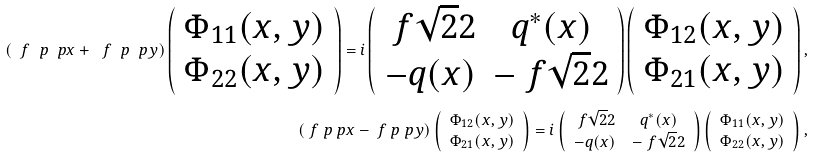Convert formula to latex. <formula><loc_0><loc_0><loc_500><loc_500>\left ( \ f \ p { \ p x } + \ f \ p { \ p y } \right ) \left ( \begin{array} { c } \Phi _ { 1 1 } ( x , y ) \\ \Phi _ { 2 2 } ( x , y ) \end{array} \right ) = i \left ( \begin{array} { c c } \ f { \sqrt { 2 } } 2 & q ^ { * } ( x ) \\ - q ( x ) & - \ f { \sqrt { 2 } } 2 \end{array} \right ) \left ( \begin{array} { c } \Phi _ { 1 2 } ( x , y ) \\ \Phi _ { 2 1 } ( x , y ) \end{array} \right ) , \\ \left ( \ f \ p { \ p x } - \ f \ p { \ p y } \right ) \left ( \begin{array} { c } \Phi _ { 1 2 } ( x , y ) \\ \Phi _ { 2 1 } ( x , y ) \end{array} \right ) = i \left ( \begin{array} { c c } \ f { \sqrt { 2 } } 2 & q ^ { * } ( x ) \\ - q ( x ) & - \ f { \sqrt { 2 } } 2 \end{array} \right ) \left ( \begin{array} { c } \Phi _ { 1 1 } ( x , y ) \\ \Phi _ { 2 2 } ( x , y ) \end{array} \right ) ,</formula> 